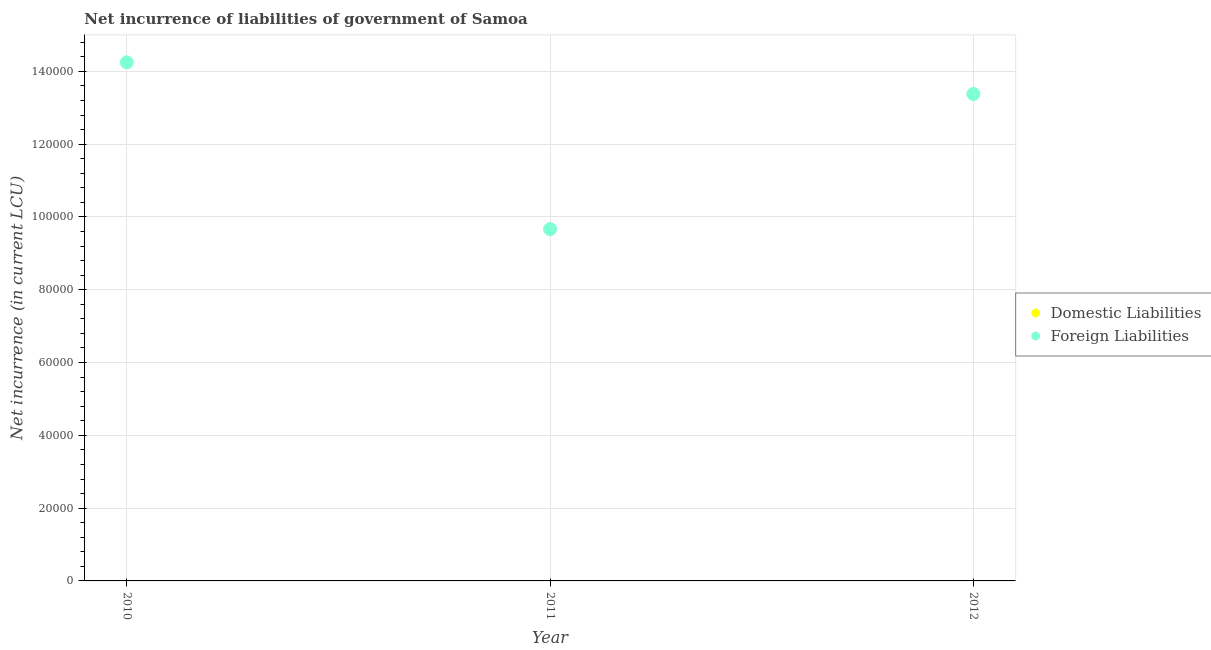Is the number of dotlines equal to the number of legend labels?
Make the answer very short. No. What is the net incurrence of foreign liabilities in 2011?
Your answer should be compact. 9.67e+04. Across all years, what is the maximum net incurrence of foreign liabilities?
Keep it short and to the point. 1.43e+05. Across all years, what is the minimum net incurrence of foreign liabilities?
Provide a succinct answer. 9.67e+04. What is the difference between the net incurrence of foreign liabilities in 2010 and that in 2011?
Ensure brevity in your answer.  4.58e+04. What is the difference between the net incurrence of domestic liabilities in 2011 and the net incurrence of foreign liabilities in 2012?
Your response must be concise. -1.34e+05. What is the average net incurrence of domestic liabilities per year?
Ensure brevity in your answer.  0. What is the ratio of the net incurrence of foreign liabilities in 2010 to that in 2012?
Make the answer very short. 1.07. What is the difference between the highest and the second highest net incurrence of foreign liabilities?
Make the answer very short. 8704.94. What is the difference between the highest and the lowest net incurrence of foreign liabilities?
Your answer should be very brief. 4.58e+04. In how many years, is the net incurrence of foreign liabilities greater than the average net incurrence of foreign liabilities taken over all years?
Provide a short and direct response. 2. How many dotlines are there?
Provide a short and direct response. 1. How many years are there in the graph?
Ensure brevity in your answer.  3. Are the values on the major ticks of Y-axis written in scientific E-notation?
Give a very brief answer. No. Where does the legend appear in the graph?
Your response must be concise. Center right. How are the legend labels stacked?
Give a very brief answer. Vertical. What is the title of the graph?
Keep it short and to the point. Net incurrence of liabilities of government of Samoa. Does "Urban agglomerations" appear as one of the legend labels in the graph?
Your answer should be very brief. No. What is the label or title of the X-axis?
Your answer should be very brief. Year. What is the label or title of the Y-axis?
Your answer should be very brief. Net incurrence (in current LCU). What is the Net incurrence (in current LCU) of Domestic Liabilities in 2010?
Make the answer very short. 0. What is the Net incurrence (in current LCU) of Foreign Liabilities in 2010?
Offer a very short reply. 1.43e+05. What is the Net incurrence (in current LCU) in Foreign Liabilities in 2011?
Offer a very short reply. 9.67e+04. What is the Net incurrence (in current LCU) in Domestic Liabilities in 2012?
Offer a terse response. 0. What is the Net incurrence (in current LCU) of Foreign Liabilities in 2012?
Keep it short and to the point. 1.34e+05. Across all years, what is the maximum Net incurrence (in current LCU) in Foreign Liabilities?
Keep it short and to the point. 1.43e+05. Across all years, what is the minimum Net incurrence (in current LCU) in Foreign Liabilities?
Your answer should be compact. 9.67e+04. What is the total Net incurrence (in current LCU) of Domestic Liabilities in the graph?
Offer a terse response. 0. What is the total Net incurrence (in current LCU) of Foreign Liabilities in the graph?
Your answer should be compact. 3.73e+05. What is the difference between the Net incurrence (in current LCU) in Foreign Liabilities in 2010 and that in 2011?
Give a very brief answer. 4.58e+04. What is the difference between the Net incurrence (in current LCU) in Foreign Liabilities in 2010 and that in 2012?
Provide a short and direct response. 8704.94. What is the difference between the Net incurrence (in current LCU) of Foreign Liabilities in 2011 and that in 2012?
Provide a succinct answer. -3.71e+04. What is the average Net incurrence (in current LCU) of Domestic Liabilities per year?
Give a very brief answer. 0. What is the average Net incurrence (in current LCU) of Foreign Liabilities per year?
Provide a short and direct response. 1.24e+05. What is the ratio of the Net incurrence (in current LCU) of Foreign Liabilities in 2010 to that in 2011?
Offer a very short reply. 1.47. What is the ratio of the Net incurrence (in current LCU) of Foreign Liabilities in 2010 to that in 2012?
Ensure brevity in your answer.  1.07. What is the ratio of the Net incurrence (in current LCU) in Foreign Liabilities in 2011 to that in 2012?
Offer a very short reply. 0.72. What is the difference between the highest and the second highest Net incurrence (in current LCU) of Foreign Liabilities?
Your response must be concise. 8704.94. What is the difference between the highest and the lowest Net incurrence (in current LCU) of Foreign Liabilities?
Keep it short and to the point. 4.58e+04. 